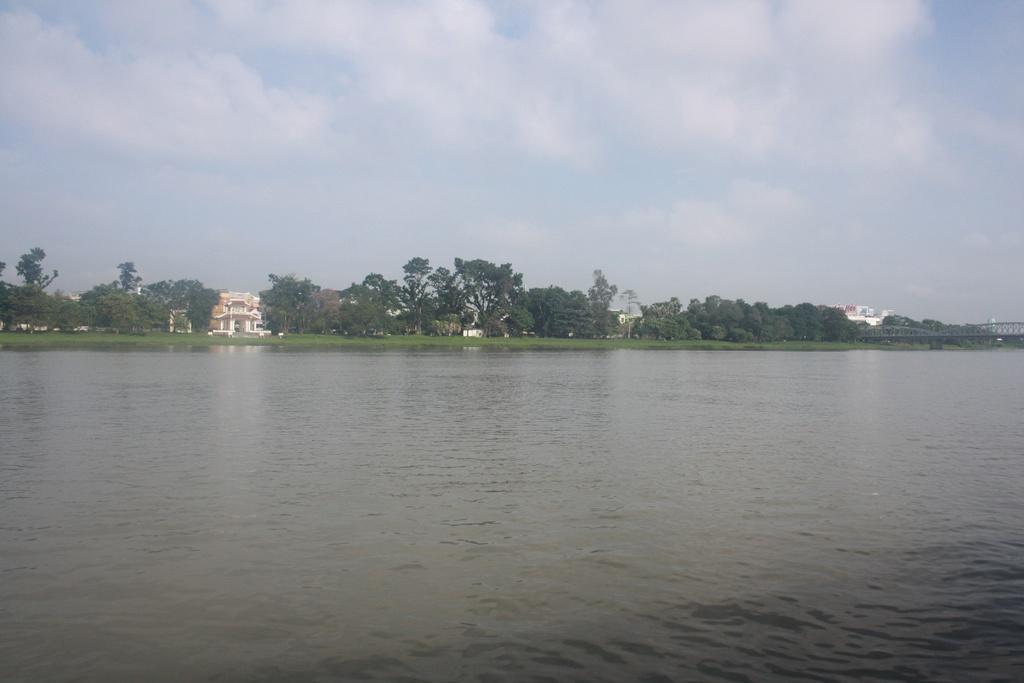Describe this image in one or two sentences. In this image, this looks like a river with the water flowing. These are the trees. I can see the buildings. This is the sky. On the right side of the image, that looks like a bridge. 